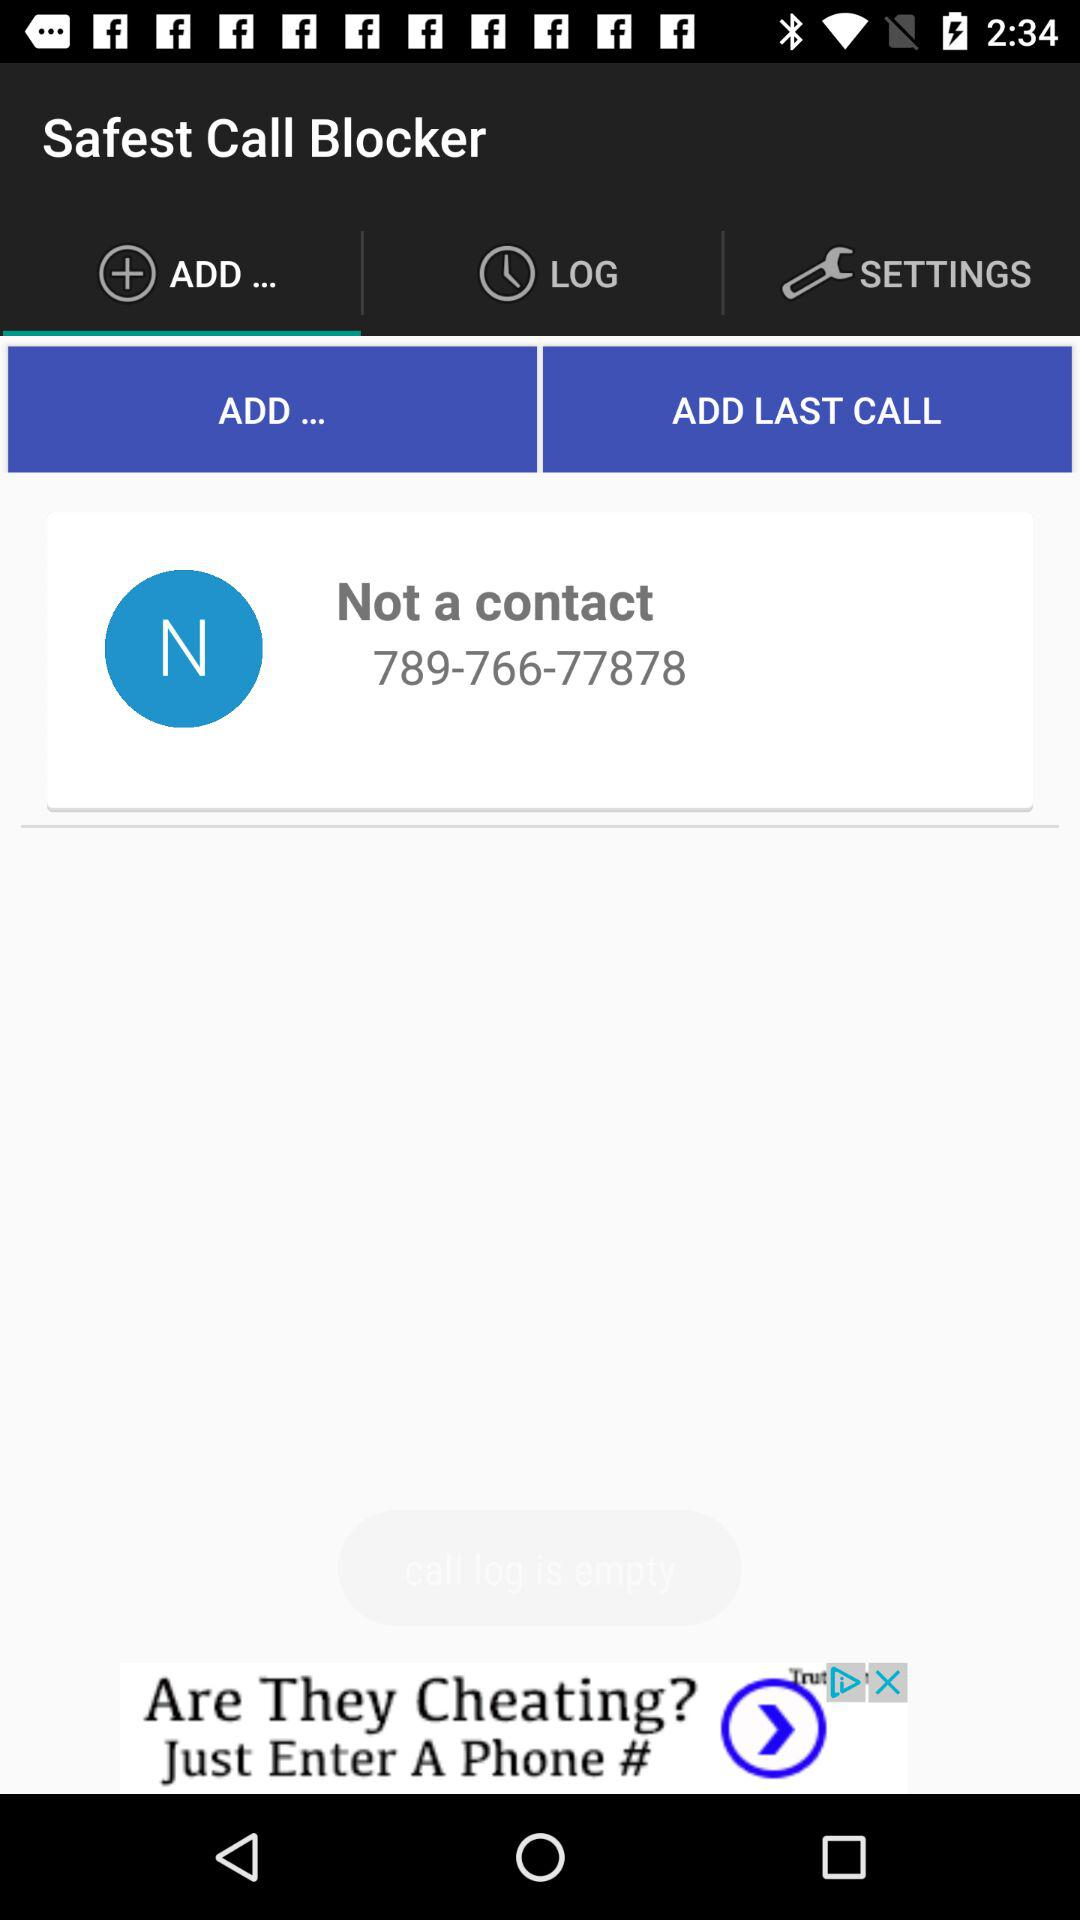Which tab is selected? The selected tab is "ADD...". 